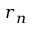<formula> <loc_0><loc_0><loc_500><loc_500>r _ { n }</formula> 